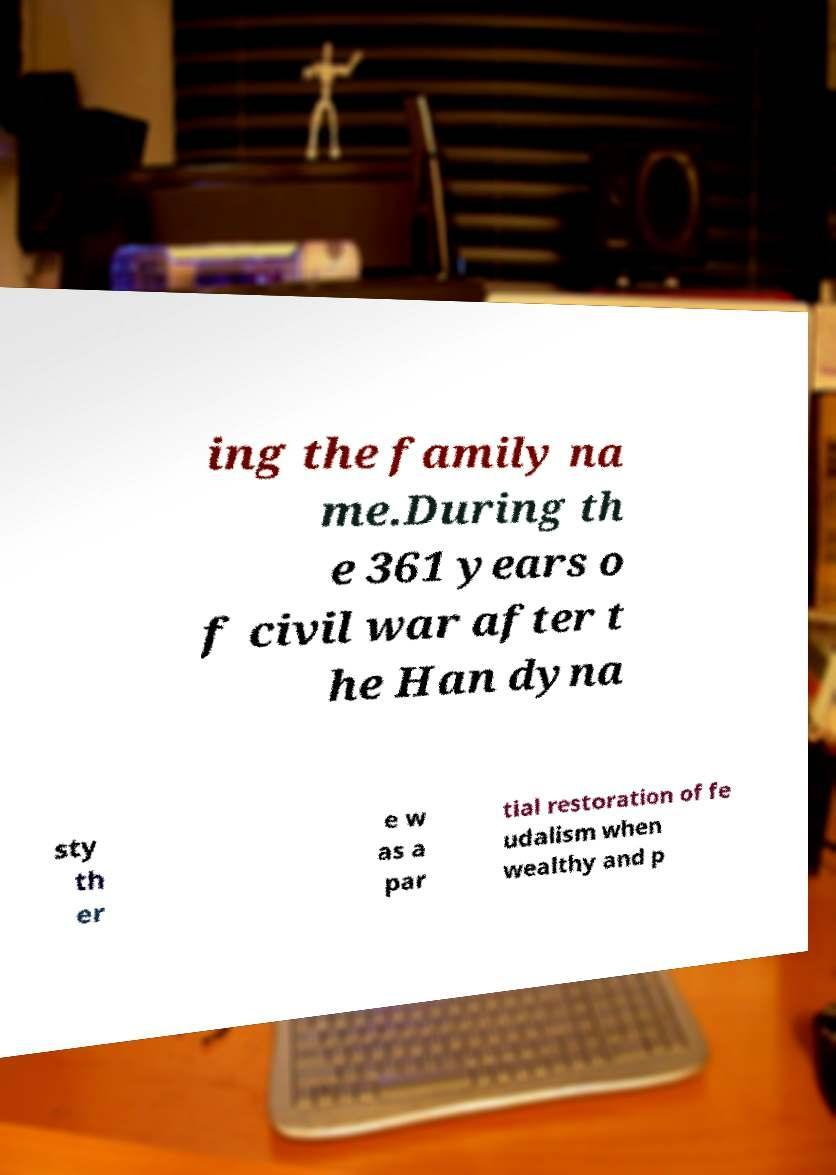Please identify and transcribe the text found in this image. ing the family na me.During th e 361 years o f civil war after t he Han dyna sty th er e w as a par tial restoration of fe udalism when wealthy and p 